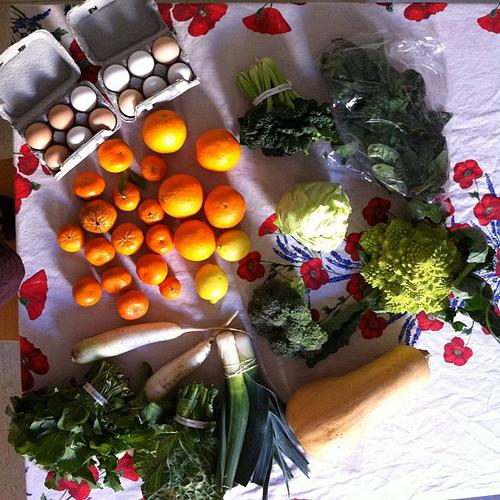Question: what color are the oranges?
Choices:
A. Red.
B. Orange.
C. Yellow.
D. Dark orange.
Answer with the letter. Answer: B Question: what is on the table?
Choices:
A. Paper.
B. Plates.
C. Remote.
D. Food.
Answer with the letter. Answer: D Question: what color is the egg carton?
Choices:
A. Black.
B. White.
C. Brown.
D. Gray.
Answer with the letter. Answer: D Question: how many pieces of food is there?
Choices:
A. Three.
B. More than five.
C. More than seven.
D. Four.
Answer with the letter. Answer: B Question: where was the photo taken?
Choices:
A. Kitchen table.
B. In front of a tattoo shop.
C. At the airport.
D. At a bowling alley.
Answer with the letter. Answer: A 